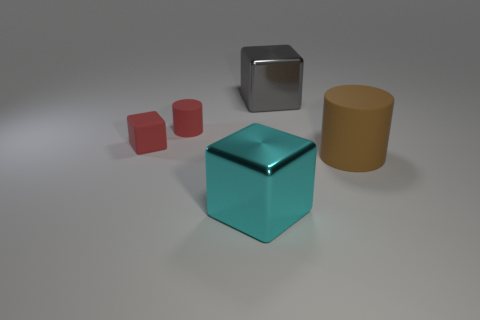The matte cylinder that is the same size as the matte block is what color?
Your answer should be very brief. Red. What is the cylinder right of the gray metal block made of?
Keep it short and to the point. Rubber. Does the big shiny thing behind the large cyan shiny cube have the same shape as the large brown rubber object that is behind the big cyan thing?
Make the answer very short. No. Are there the same number of metal blocks that are in front of the large brown object and tiny cylinders?
Provide a succinct answer. Yes. How many small red blocks are made of the same material as the big gray cube?
Give a very brief answer. 0. There is a cube that is the same material as the brown cylinder; what is its color?
Make the answer very short. Red. Does the cyan object have the same size as the red object in front of the red cylinder?
Keep it short and to the point. No. The big rubber object has what shape?
Offer a very short reply. Cylinder. What number of small cubes are the same color as the large cylinder?
Your answer should be very brief. 0. What is the color of the other metal thing that is the same shape as the big cyan object?
Offer a terse response. Gray. 